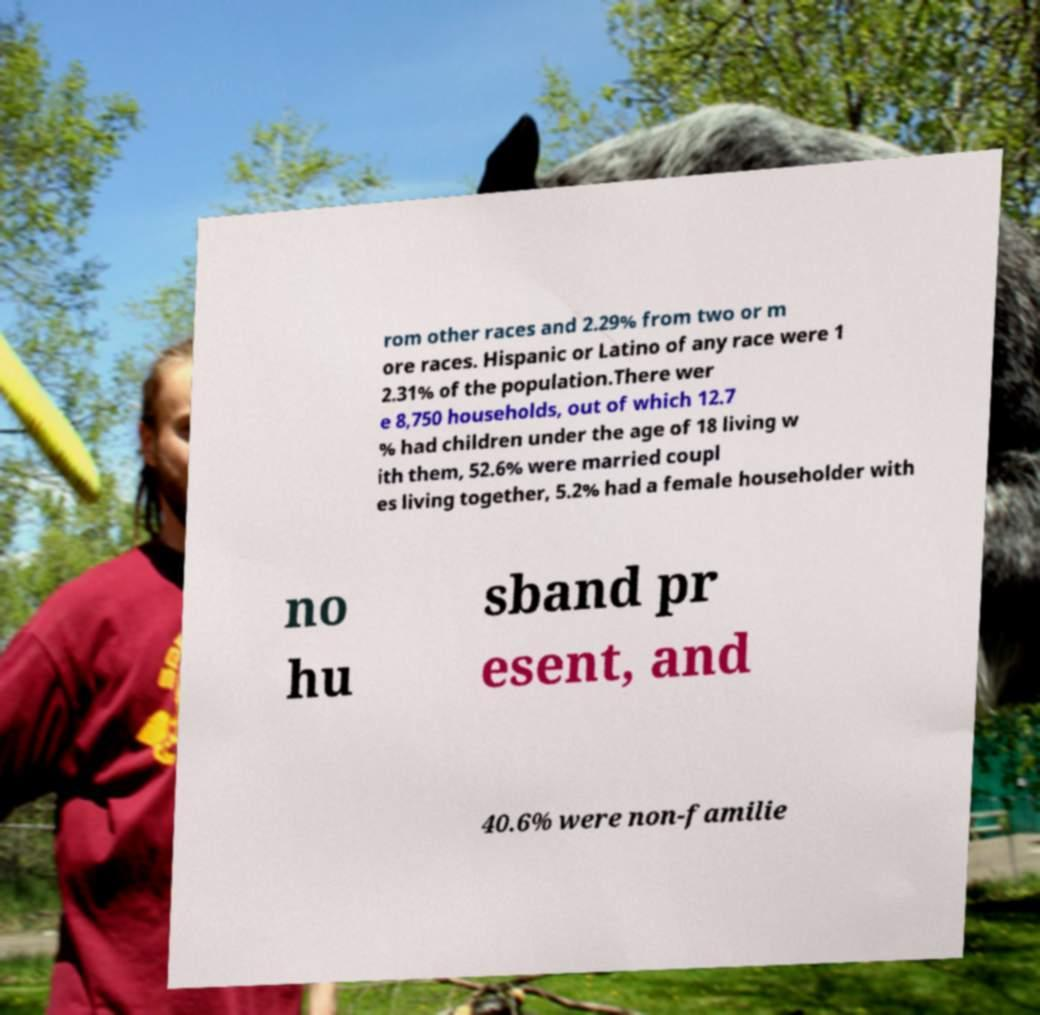Can you accurately transcribe the text from the provided image for me? rom other races and 2.29% from two or m ore races. Hispanic or Latino of any race were 1 2.31% of the population.There wer e 8,750 households, out of which 12.7 % had children under the age of 18 living w ith them, 52.6% were married coupl es living together, 5.2% had a female householder with no hu sband pr esent, and 40.6% were non-familie 